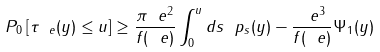Convert formula to latex. <formula><loc_0><loc_0><loc_500><loc_500>P _ { 0 } \left [ \tau _ { \ e } ( y ) \leq u \right ] \geq \frac { \pi \ e ^ { 2 } } { f ( \ e ) } \int _ { 0 } ^ { u } d s \ p _ { s } ( y ) - \frac { \ e ^ { 3 } } { f ( \ e ) } \Psi _ { 1 } ( y )</formula> 